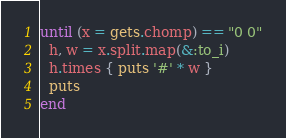<code> <loc_0><loc_0><loc_500><loc_500><_Ruby_>until (x = gets.chomp) == "0 0"
  h, w = x.split.map(&:to_i)
  h.times { puts '#' * w }
  puts
end</code> 